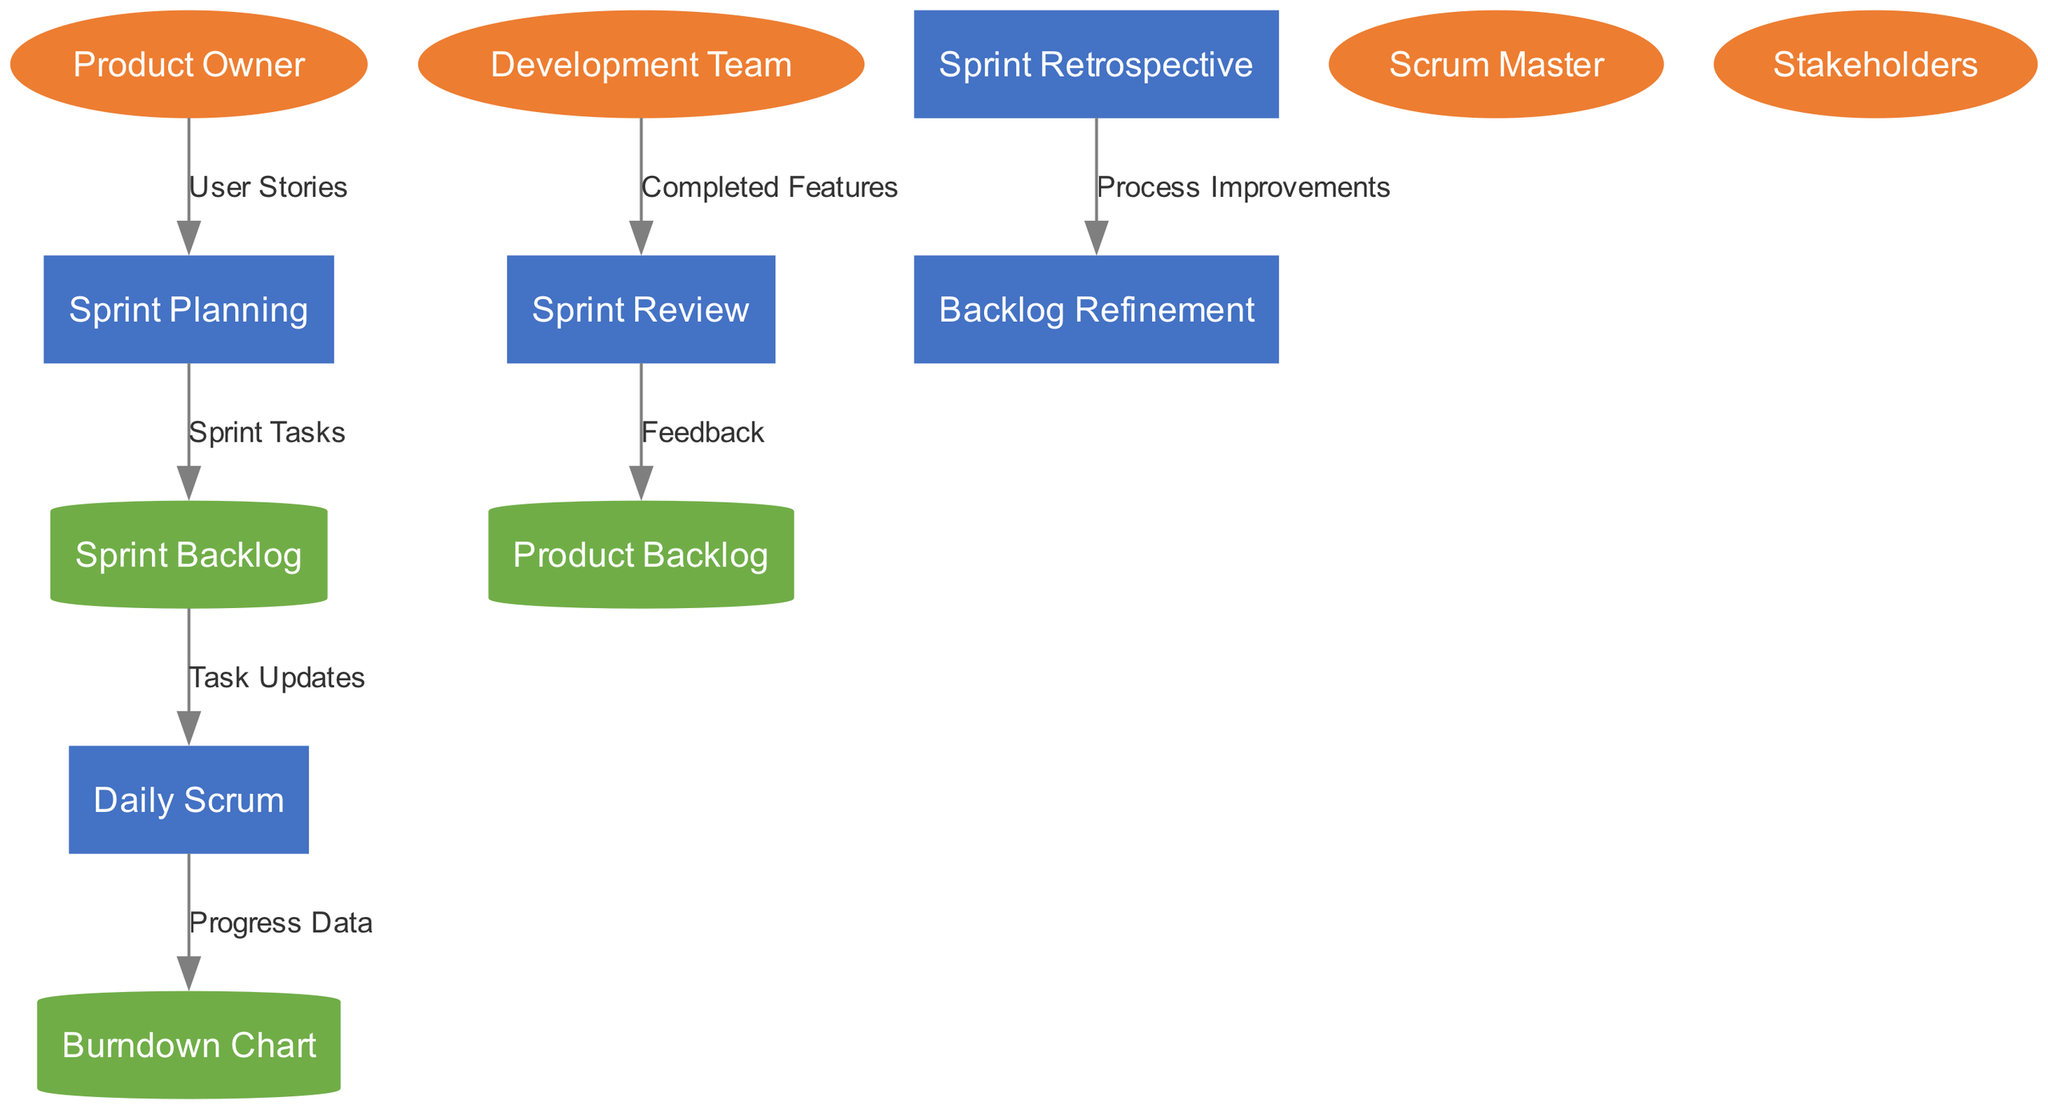What are the processes in the diagram? The diagram lists five processes: Sprint Planning, Daily Scrum, Sprint Review, Sprint Retrospective, and Backlog Refinement. These are visually represented and are the main workflows involved in the Agile sprint.
Answer: Sprint Planning, Daily Scrum, Sprint Review, Sprint Retrospective, Backlog Refinement How many external entities are there? The diagram shows four external entities: Product Owner, Scrum Master, Development Team, and Stakeholders. The count can be obtained by visually identifying the entities represented in ellipses.
Answer: 4 What data flows from the Daily Scrum to the Burndown Chart? The flow from Daily Scrum to Burndown Chart is labeled "Progress Data". This relationship is determined by examining the connecting edge in the diagram.
Answer: Progress Data Which process receives feedback from the Sprint Review? Feedback is sent from Sprint Review to Product Backlog. This relationship is shown in the diagram by a directed edge connecting these two nodes.
Answer: Product Backlog What is the first data flow in the workflow? The first data flow is from the Product Owner to Sprint Planning, labeled "User Stories". This is the initial step that starts the sprint workflow according to the diagram.
Answer: User Stories If the Development Team completes features, which process do they report to? The Development Team reports completed features to the Sprint Review process. This can be seen from the directed edge indicating the flow of completed features between these two processes.
Answer: Sprint Review How many processes flow into the Backlog Refinement? Only one process flows into Backlog Refinement, and that is the Sprint Retrospective, which provides "Process Improvements" as the data flow label. This can be ascertained by reviewing the connections in the diagram.
Answer: 1 Which external entity provides user stories for the Sprint Planning process? The Product Owner provides user stories to the Sprint Planning process, as indicated by the directed edge labeled "User Stories". The roles of entities are clearly defined in the diagram.
Answer: Product Owner What type of diagram is being represented? The diagram is a Data Flow Diagram (DFD), which highlights the flow of data between processes, external entities, and data stores in an Agile sprint workflow. This can be inferred from the structure and purpose of the visual representation.
Answer: Data Flow Diagram 